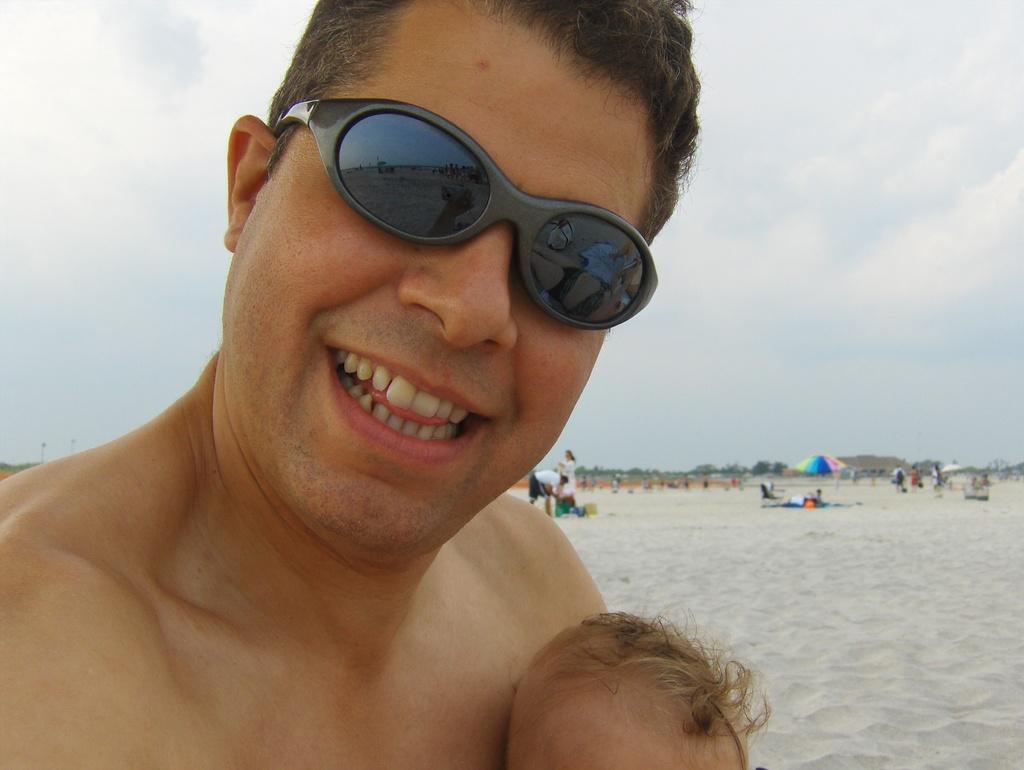Can you describe this image briefly? In this picture we can see a person wearing wearing spectacles, behind we can see few people and we can see umbrellas. 